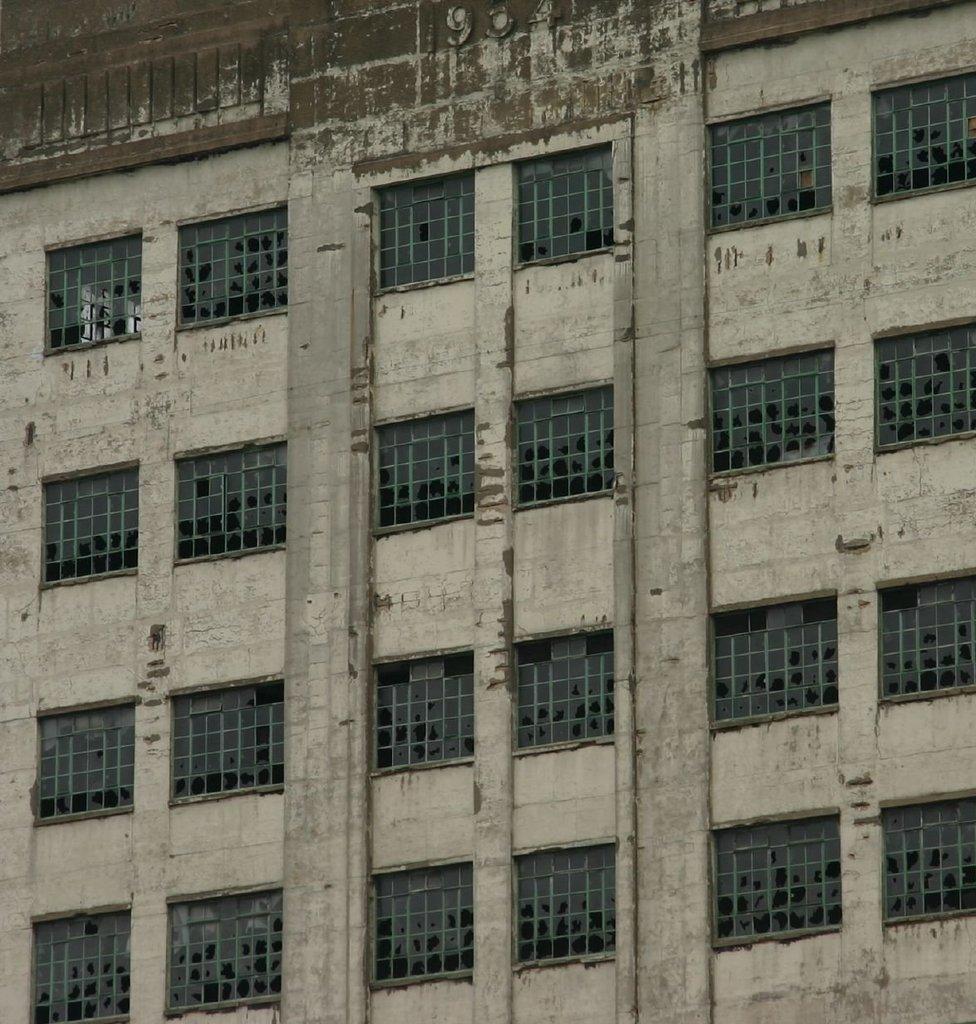Please provide a concise description of this image. In this image we can see a building with windows and pillars. 